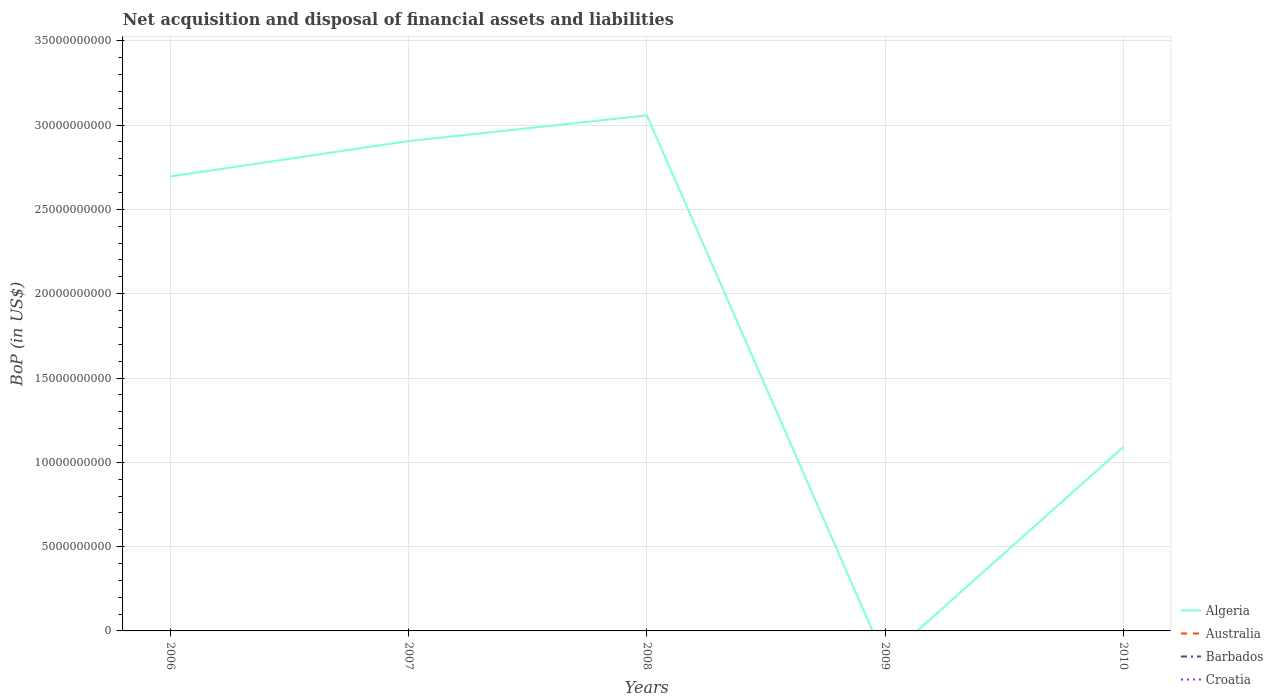How many different coloured lines are there?
Your answer should be very brief. 1. Does the line corresponding to Croatia intersect with the line corresponding to Algeria?
Keep it short and to the point. No. Is the number of lines equal to the number of legend labels?
Offer a terse response. No. Across all years, what is the maximum Balance of Payments in Algeria?
Keep it short and to the point. 0. What is the total Balance of Payments in Algeria in the graph?
Your answer should be compact. 1.60e+1. What is the difference between the highest and the lowest Balance of Payments in Barbados?
Your answer should be compact. 0. How many lines are there?
Give a very brief answer. 1. What is the difference between two consecutive major ticks on the Y-axis?
Make the answer very short. 5.00e+09. Are the values on the major ticks of Y-axis written in scientific E-notation?
Your response must be concise. No. Does the graph contain any zero values?
Ensure brevity in your answer.  Yes. What is the title of the graph?
Make the answer very short. Net acquisition and disposal of financial assets and liabilities. What is the label or title of the X-axis?
Offer a terse response. Years. What is the label or title of the Y-axis?
Offer a very short reply. BoP (in US$). What is the BoP (in US$) in Algeria in 2006?
Your response must be concise. 2.70e+1. What is the BoP (in US$) in Australia in 2006?
Your answer should be compact. 0. What is the BoP (in US$) in Algeria in 2007?
Ensure brevity in your answer.  2.91e+1. What is the BoP (in US$) of Australia in 2007?
Your answer should be very brief. 0. What is the BoP (in US$) of Croatia in 2007?
Make the answer very short. 0. What is the BoP (in US$) in Algeria in 2008?
Provide a short and direct response. 3.06e+1. What is the BoP (in US$) of Australia in 2008?
Your response must be concise. 0. What is the BoP (in US$) in Barbados in 2009?
Make the answer very short. 0. What is the BoP (in US$) in Croatia in 2009?
Give a very brief answer. 0. What is the BoP (in US$) of Algeria in 2010?
Keep it short and to the point. 1.09e+1. What is the BoP (in US$) in Barbados in 2010?
Your answer should be very brief. 0. Across all years, what is the maximum BoP (in US$) of Algeria?
Ensure brevity in your answer.  3.06e+1. Across all years, what is the minimum BoP (in US$) of Algeria?
Ensure brevity in your answer.  0. What is the total BoP (in US$) of Algeria in the graph?
Offer a very short reply. 9.75e+1. What is the total BoP (in US$) in Australia in the graph?
Your response must be concise. 0. What is the difference between the BoP (in US$) of Algeria in 2006 and that in 2007?
Provide a succinct answer. -2.10e+09. What is the difference between the BoP (in US$) of Algeria in 2006 and that in 2008?
Offer a terse response. -3.62e+09. What is the difference between the BoP (in US$) of Algeria in 2006 and that in 2010?
Your answer should be very brief. 1.60e+1. What is the difference between the BoP (in US$) of Algeria in 2007 and that in 2008?
Your answer should be very brief. -1.52e+09. What is the difference between the BoP (in US$) of Algeria in 2007 and that in 2010?
Keep it short and to the point. 1.81e+1. What is the difference between the BoP (in US$) of Algeria in 2008 and that in 2010?
Offer a terse response. 1.97e+1. What is the average BoP (in US$) of Algeria per year?
Ensure brevity in your answer.  1.95e+1. What is the average BoP (in US$) in Australia per year?
Your response must be concise. 0. What is the average BoP (in US$) in Barbados per year?
Provide a succinct answer. 0. What is the ratio of the BoP (in US$) of Algeria in 2006 to that in 2007?
Your response must be concise. 0.93. What is the ratio of the BoP (in US$) in Algeria in 2006 to that in 2008?
Your answer should be compact. 0.88. What is the ratio of the BoP (in US$) in Algeria in 2006 to that in 2010?
Your response must be concise. 2.47. What is the ratio of the BoP (in US$) in Algeria in 2007 to that in 2008?
Provide a short and direct response. 0.95. What is the ratio of the BoP (in US$) of Algeria in 2007 to that in 2010?
Your response must be concise. 2.66. What is the ratio of the BoP (in US$) of Algeria in 2008 to that in 2010?
Give a very brief answer. 2.8. What is the difference between the highest and the second highest BoP (in US$) in Algeria?
Your answer should be compact. 1.52e+09. What is the difference between the highest and the lowest BoP (in US$) of Algeria?
Provide a succinct answer. 3.06e+1. 